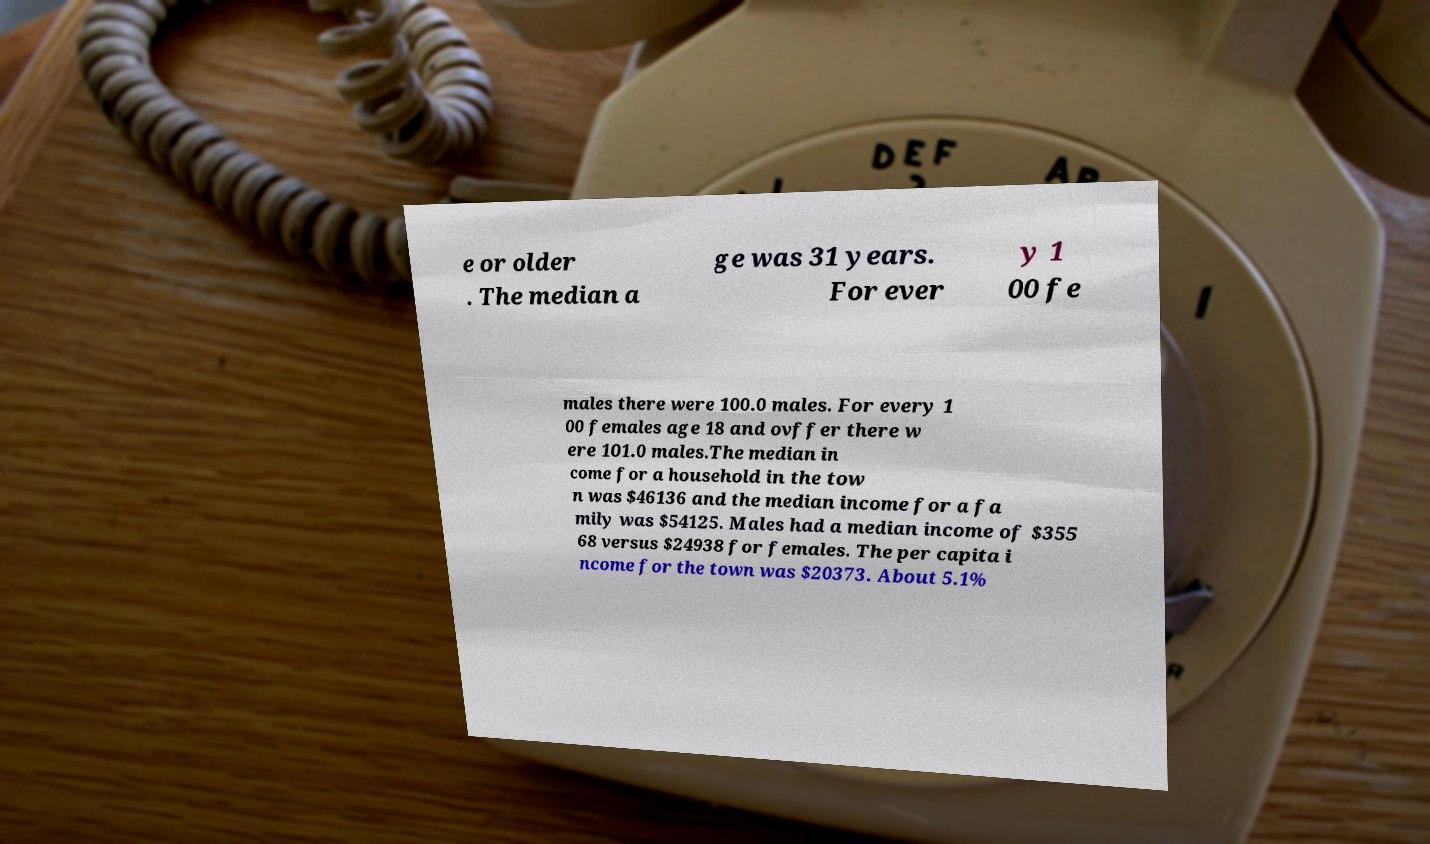I need the written content from this picture converted into text. Can you do that? e or older . The median a ge was 31 years. For ever y 1 00 fe males there were 100.0 males. For every 1 00 females age 18 and ovffer there w ere 101.0 males.The median in come for a household in the tow n was $46136 and the median income for a fa mily was $54125. Males had a median income of $355 68 versus $24938 for females. The per capita i ncome for the town was $20373. About 5.1% 